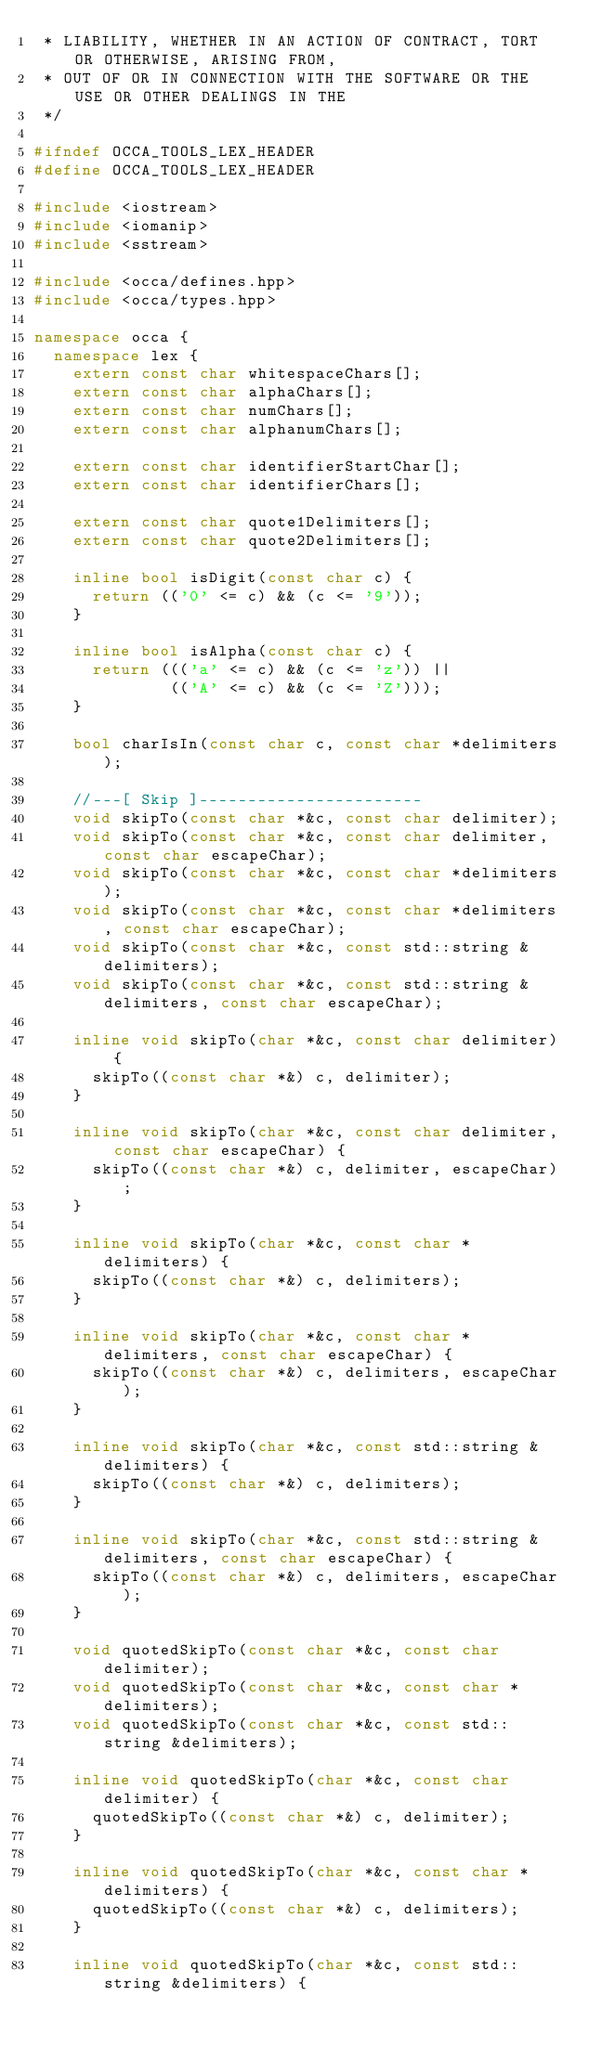<code> <loc_0><loc_0><loc_500><loc_500><_C++_> * LIABILITY, WHETHER IN AN ACTION OF CONTRACT, TORT OR OTHERWISE, ARISING FROM,
 * OUT OF OR IN CONNECTION WITH THE SOFTWARE OR THE USE OR OTHER DEALINGS IN THE
 */

#ifndef OCCA_TOOLS_LEX_HEADER
#define OCCA_TOOLS_LEX_HEADER

#include <iostream>
#include <iomanip>
#include <sstream>

#include <occa/defines.hpp>
#include <occa/types.hpp>

namespace occa {
  namespace lex {
    extern const char whitespaceChars[];
    extern const char alphaChars[];
    extern const char numChars[];
    extern const char alphanumChars[];

    extern const char identifierStartChar[];
    extern const char identifierChars[];

    extern const char quote1Delimiters[];
    extern const char quote2Delimiters[];

    inline bool isDigit(const char c) {
      return (('0' <= c) && (c <= '9'));
    }

    inline bool isAlpha(const char c) {
      return ((('a' <= c) && (c <= 'z')) ||
              (('A' <= c) && (c <= 'Z')));
    }

    bool charIsIn(const char c, const char *delimiters);

    //---[ Skip ]-----------------------
    void skipTo(const char *&c, const char delimiter);
    void skipTo(const char *&c, const char delimiter, const char escapeChar);
    void skipTo(const char *&c, const char *delimiters);
    void skipTo(const char *&c, const char *delimiters, const char escapeChar);
    void skipTo(const char *&c, const std::string &delimiters);
    void skipTo(const char *&c, const std::string &delimiters, const char escapeChar);

    inline void skipTo(char *&c, const char delimiter) {
      skipTo((const char *&) c, delimiter);
    }

    inline void skipTo(char *&c, const char delimiter, const char escapeChar) {
      skipTo((const char *&) c, delimiter, escapeChar);
    }

    inline void skipTo(char *&c, const char *delimiters) {
      skipTo((const char *&) c, delimiters);
    }

    inline void skipTo(char *&c, const char *delimiters, const char escapeChar) {
      skipTo((const char *&) c, delimiters, escapeChar);
    }

    inline void skipTo(char *&c, const std::string &delimiters) {
      skipTo((const char *&) c, delimiters);
    }

    inline void skipTo(char *&c, const std::string &delimiters, const char escapeChar) {
      skipTo((const char *&) c, delimiters, escapeChar);
    }

    void quotedSkipTo(const char *&c, const char delimiter);
    void quotedSkipTo(const char *&c, const char *delimiters);
    void quotedSkipTo(const char *&c, const std::string &delimiters);

    inline void quotedSkipTo(char *&c, const char delimiter) {
      quotedSkipTo((const char *&) c, delimiter);
    }

    inline void quotedSkipTo(char *&c, const char *delimiters) {
      quotedSkipTo((const char *&) c, delimiters);
    }

    inline void quotedSkipTo(char *&c, const std::string &delimiters) {</code> 